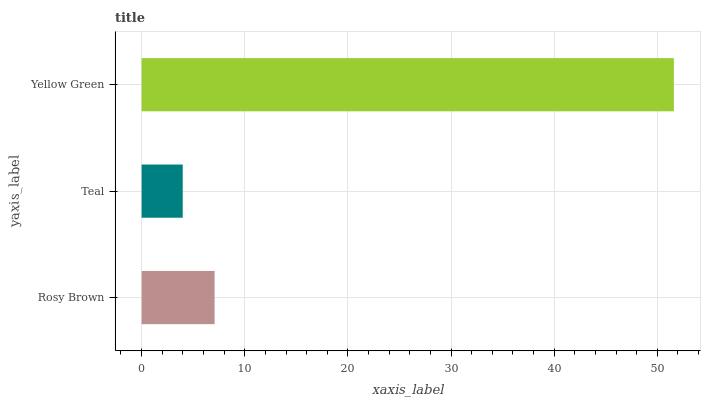Is Teal the minimum?
Answer yes or no. Yes. Is Yellow Green the maximum?
Answer yes or no. Yes. Is Yellow Green the minimum?
Answer yes or no. No. Is Teal the maximum?
Answer yes or no. No. Is Yellow Green greater than Teal?
Answer yes or no. Yes. Is Teal less than Yellow Green?
Answer yes or no. Yes. Is Teal greater than Yellow Green?
Answer yes or no. No. Is Yellow Green less than Teal?
Answer yes or no. No. Is Rosy Brown the high median?
Answer yes or no. Yes. Is Rosy Brown the low median?
Answer yes or no. Yes. Is Teal the high median?
Answer yes or no. No. Is Yellow Green the low median?
Answer yes or no. No. 